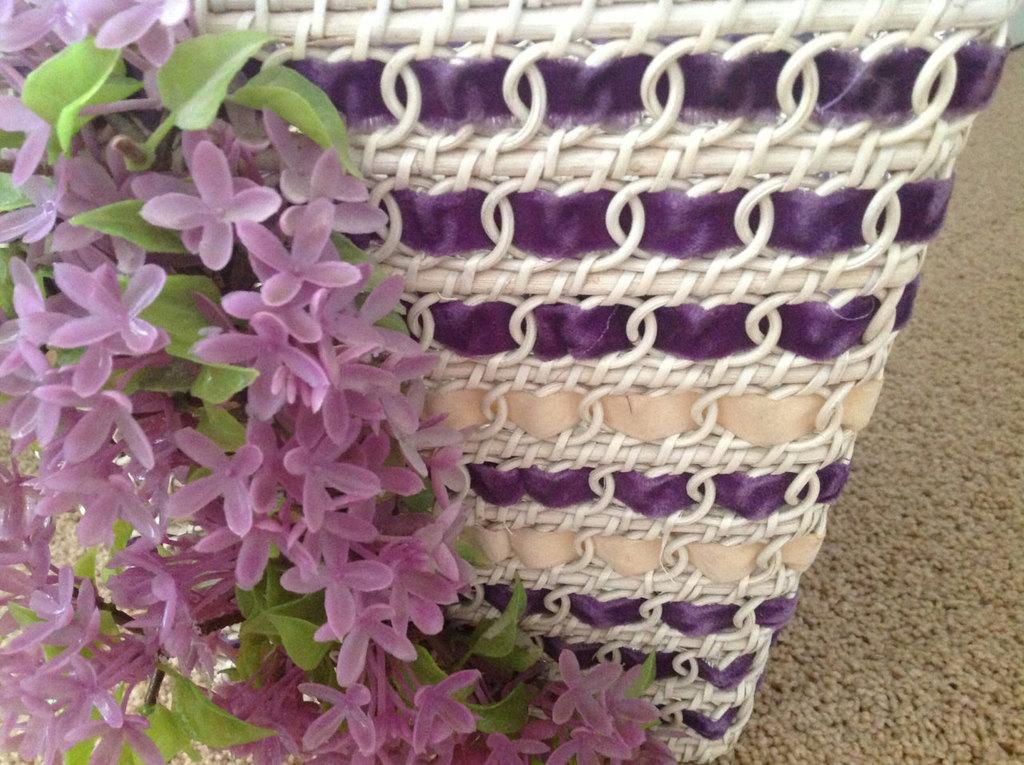What is the main subject of the image? There is a decor item in the image. Where is the decor item located? The decor item is placed on the road. How many geese are walking through the market in the image? There are no geese or market present in the image; it features a decor item placed on the road. What type of patch can be seen on the decor item in the image? There is no patch visible on the decor item in the image. 